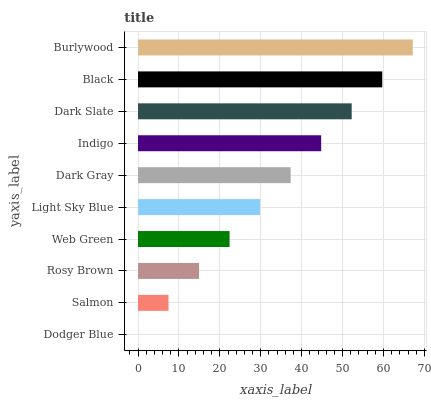Is Dodger Blue the minimum?
Answer yes or no. Yes. Is Burlywood the maximum?
Answer yes or no. Yes. Is Salmon the minimum?
Answer yes or no. No. Is Salmon the maximum?
Answer yes or no. No. Is Salmon greater than Dodger Blue?
Answer yes or no. Yes. Is Dodger Blue less than Salmon?
Answer yes or no. Yes. Is Dodger Blue greater than Salmon?
Answer yes or no. No. Is Salmon less than Dodger Blue?
Answer yes or no. No. Is Dark Gray the high median?
Answer yes or no. Yes. Is Light Sky Blue the low median?
Answer yes or no. Yes. Is Indigo the high median?
Answer yes or no. No. Is Dark Slate the low median?
Answer yes or no. No. 